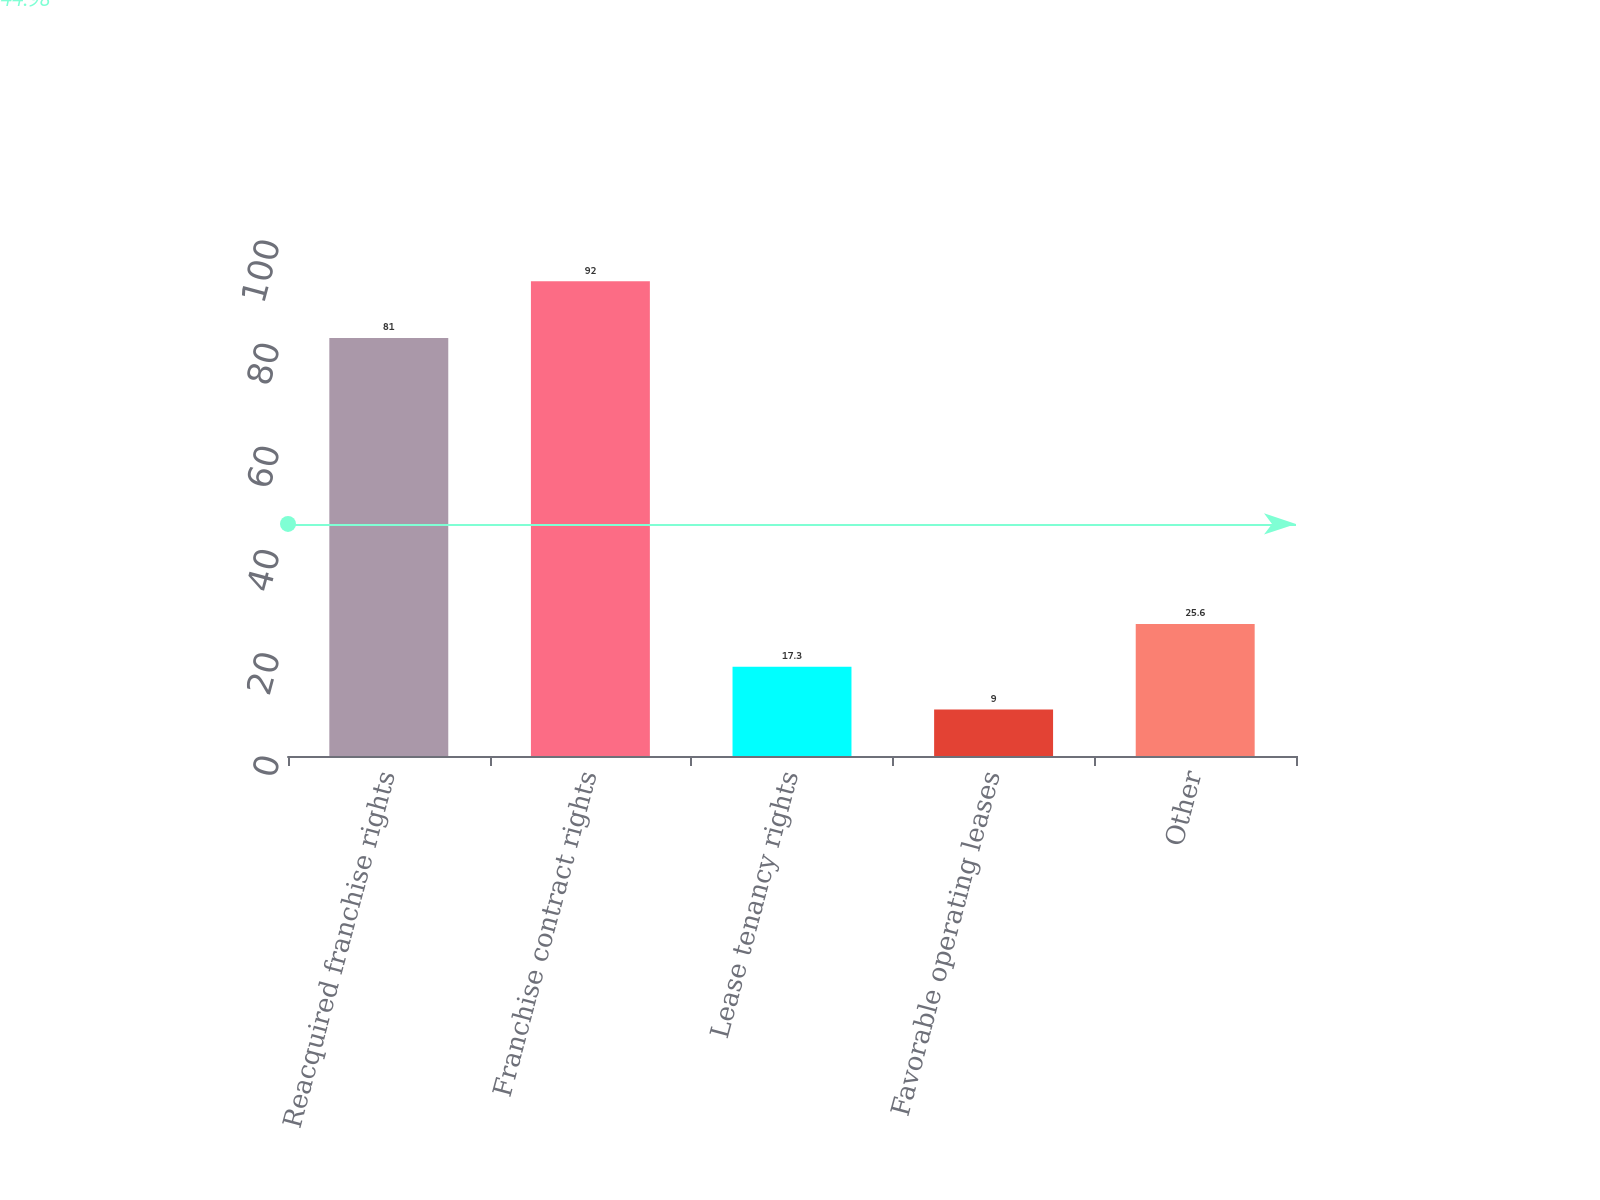<chart> <loc_0><loc_0><loc_500><loc_500><bar_chart><fcel>Reacquired franchise rights<fcel>Franchise contract rights<fcel>Lease tenancy rights<fcel>Favorable operating leases<fcel>Other<nl><fcel>81<fcel>92<fcel>17.3<fcel>9<fcel>25.6<nl></chart> 